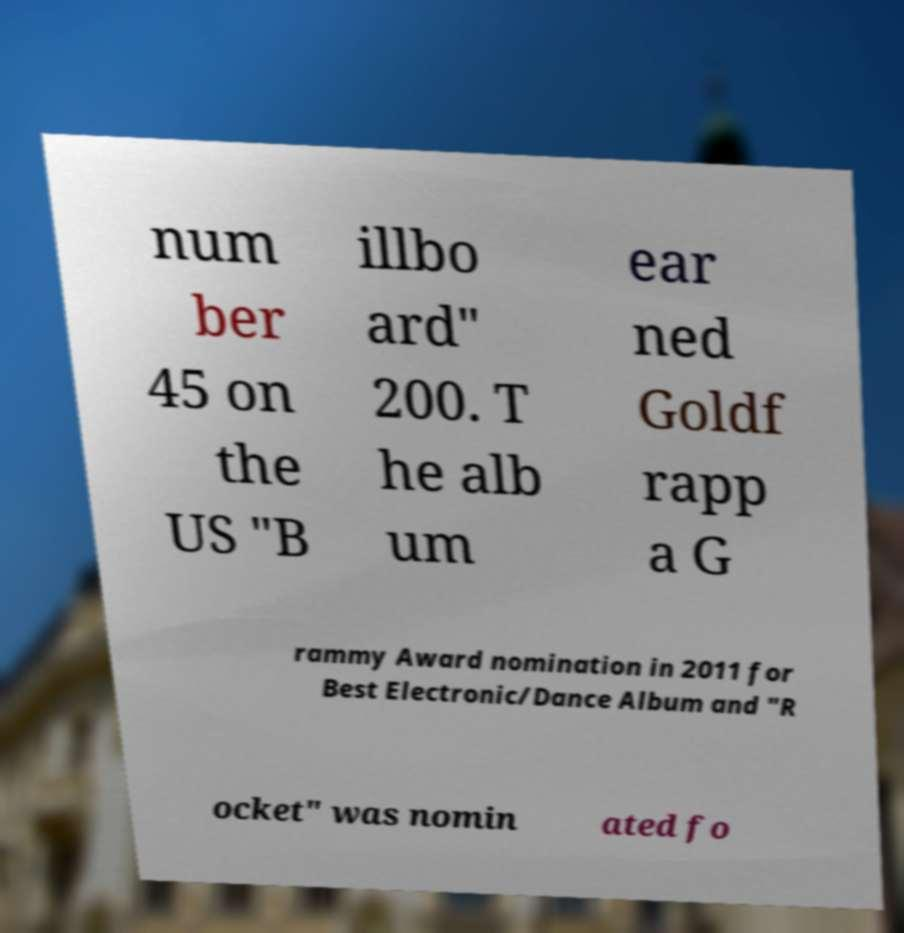What messages or text are displayed in this image? I need them in a readable, typed format. num ber 45 on the US "B illbo ard" 200. T he alb um ear ned Goldf rapp a G rammy Award nomination in 2011 for Best Electronic/Dance Album and "R ocket" was nomin ated fo 